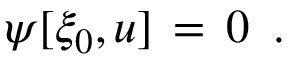Convert formula to latex. <formula><loc_0><loc_0><loc_500><loc_500>\begin{array} { r } { \psi [ \xi _ { 0 } , u ] \, = \, 0 \ \, . \quad } \end{array}</formula> 